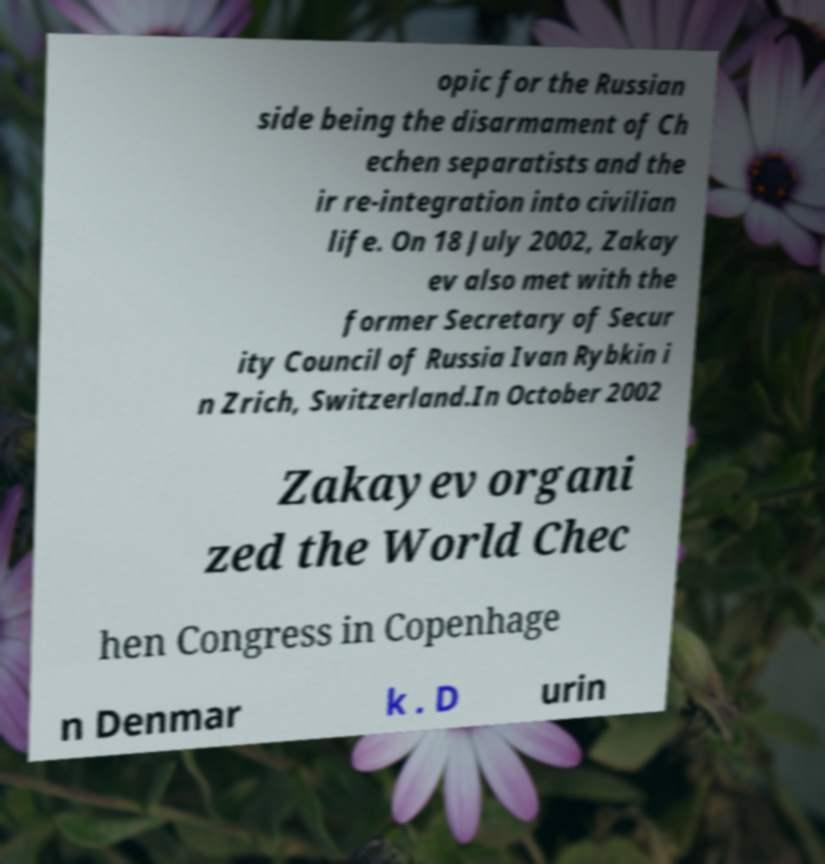Could you assist in decoding the text presented in this image and type it out clearly? opic for the Russian side being the disarmament of Ch echen separatists and the ir re-integration into civilian life. On 18 July 2002, Zakay ev also met with the former Secretary of Secur ity Council of Russia Ivan Rybkin i n Zrich, Switzerland.In October 2002 Zakayev organi zed the World Chec hen Congress in Copenhage n Denmar k . D urin 